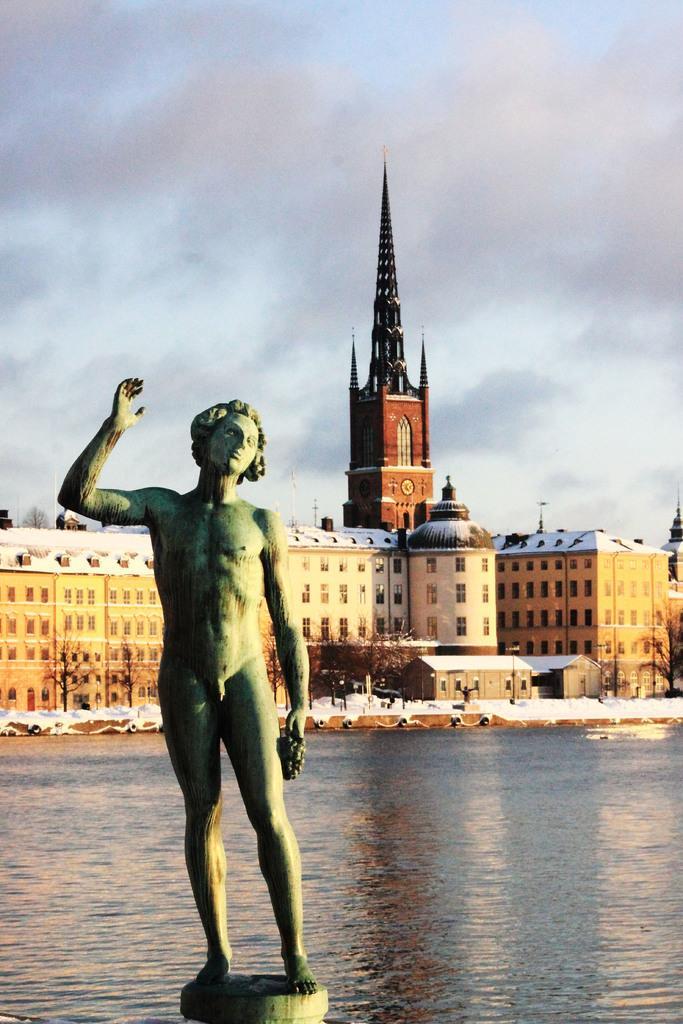Could you give a brief overview of what you see in this image? In this picture we can observe a statue of a person. We can observe water. In the background there is a building and a tower. We can observe a sky with clouds. 